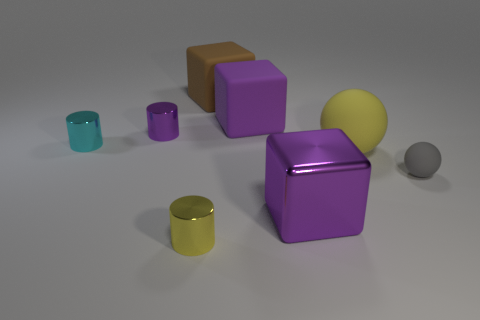Is the number of small cyan metal cylinders that are right of the tiny purple thing greater than the number of cyan rubber cubes? No, there are two small cyan metal cylinders to the right of the tiny purple object, and there are no cyan rubber cubes present in the image. 